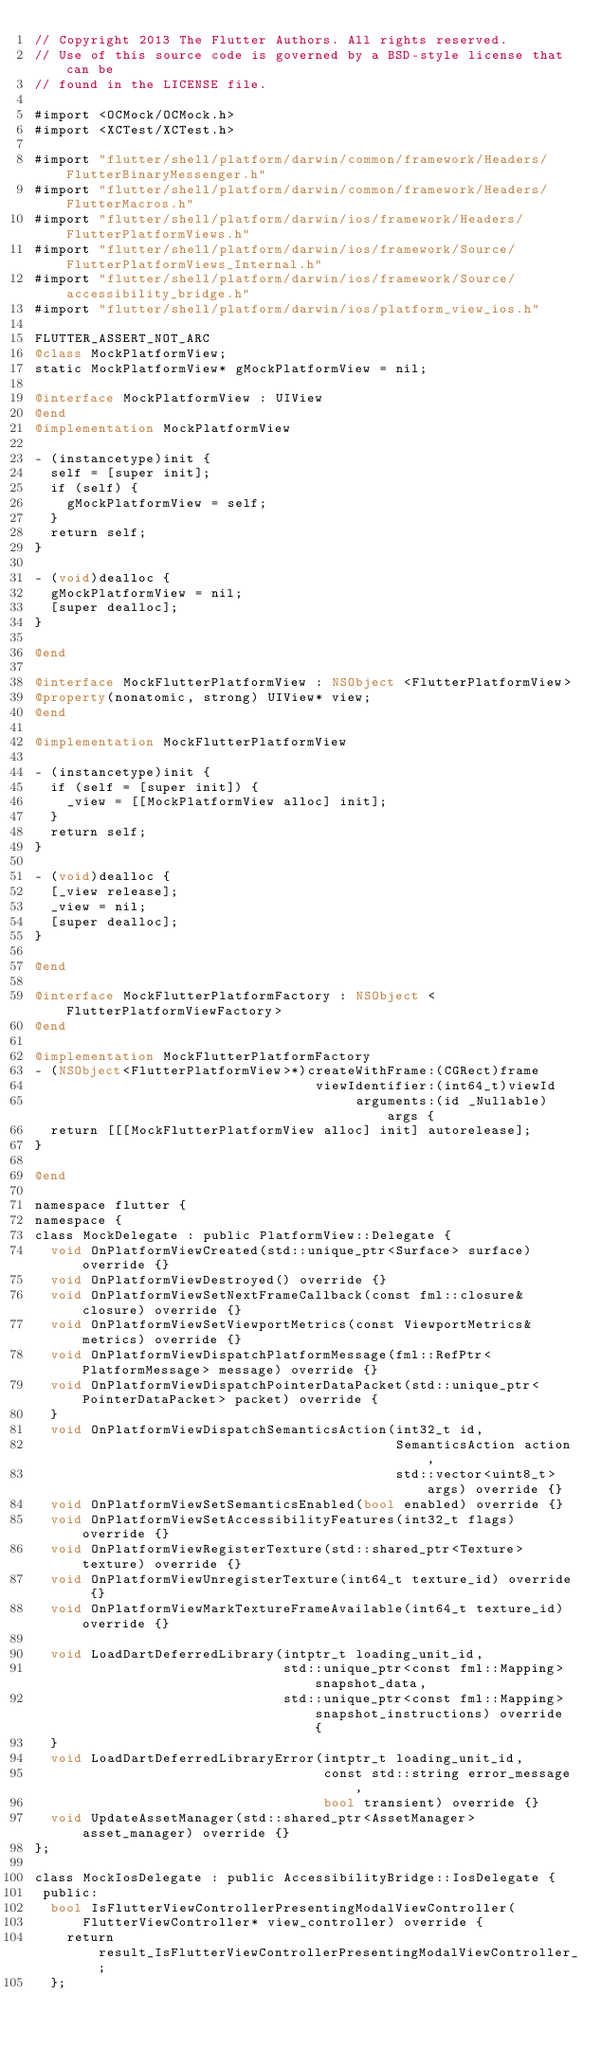<code> <loc_0><loc_0><loc_500><loc_500><_ObjectiveC_>// Copyright 2013 The Flutter Authors. All rights reserved.
// Use of this source code is governed by a BSD-style license that can be
// found in the LICENSE file.

#import <OCMock/OCMock.h>
#import <XCTest/XCTest.h>

#import "flutter/shell/platform/darwin/common/framework/Headers/FlutterBinaryMessenger.h"
#import "flutter/shell/platform/darwin/common/framework/Headers/FlutterMacros.h"
#import "flutter/shell/platform/darwin/ios/framework/Headers/FlutterPlatformViews.h"
#import "flutter/shell/platform/darwin/ios/framework/Source/FlutterPlatformViews_Internal.h"
#import "flutter/shell/platform/darwin/ios/framework/Source/accessibility_bridge.h"
#import "flutter/shell/platform/darwin/ios/platform_view_ios.h"

FLUTTER_ASSERT_NOT_ARC
@class MockPlatformView;
static MockPlatformView* gMockPlatformView = nil;

@interface MockPlatformView : UIView
@end
@implementation MockPlatformView

- (instancetype)init {
  self = [super init];
  if (self) {
    gMockPlatformView = self;
  }
  return self;
}

- (void)dealloc {
  gMockPlatformView = nil;
  [super dealloc];
}

@end

@interface MockFlutterPlatformView : NSObject <FlutterPlatformView>
@property(nonatomic, strong) UIView* view;
@end

@implementation MockFlutterPlatformView

- (instancetype)init {
  if (self = [super init]) {
    _view = [[MockPlatformView alloc] init];
  }
  return self;
}

- (void)dealloc {
  [_view release];
  _view = nil;
  [super dealloc];
}

@end

@interface MockFlutterPlatformFactory : NSObject <FlutterPlatformViewFactory>
@end

@implementation MockFlutterPlatformFactory
- (NSObject<FlutterPlatformView>*)createWithFrame:(CGRect)frame
                                   viewIdentifier:(int64_t)viewId
                                        arguments:(id _Nullable)args {
  return [[[MockFlutterPlatformView alloc] init] autorelease];
}

@end

namespace flutter {
namespace {
class MockDelegate : public PlatformView::Delegate {
  void OnPlatformViewCreated(std::unique_ptr<Surface> surface) override {}
  void OnPlatformViewDestroyed() override {}
  void OnPlatformViewSetNextFrameCallback(const fml::closure& closure) override {}
  void OnPlatformViewSetViewportMetrics(const ViewportMetrics& metrics) override {}
  void OnPlatformViewDispatchPlatformMessage(fml::RefPtr<PlatformMessage> message) override {}
  void OnPlatformViewDispatchPointerDataPacket(std::unique_ptr<PointerDataPacket> packet) override {
  }
  void OnPlatformViewDispatchSemanticsAction(int32_t id,
                                             SemanticsAction action,
                                             std::vector<uint8_t> args) override {}
  void OnPlatformViewSetSemanticsEnabled(bool enabled) override {}
  void OnPlatformViewSetAccessibilityFeatures(int32_t flags) override {}
  void OnPlatformViewRegisterTexture(std::shared_ptr<Texture> texture) override {}
  void OnPlatformViewUnregisterTexture(int64_t texture_id) override {}
  void OnPlatformViewMarkTextureFrameAvailable(int64_t texture_id) override {}

  void LoadDartDeferredLibrary(intptr_t loading_unit_id,
                               std::unique_ptr<const fml::Mapping> snapshot_data,
                               std::unique_ptr<const fml::Mapping> snapshot_instructions) override {
  }
  void LoadDartDeferredLibraryError(intptr_t loading_unit_id,
                                    const std::string error_message,
                                    bool transient) override {}
  void UpdateAssetManager(std::shared_ptr<AssetManager> asset_manager) override {}
};

class MockIosDelegate : public AccessibilityBridge::IosDelegate {
 public:
  bool IsFlutterViewControllerPresentingModalViewController(
      FlutterViewController* view_controller) override {
    return result_IsFlutterViewControllerPresentingModalViewController_;
  };
</code> 